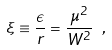Convert formula to latex. <formula><loc_0><loc_0><loc_500><loc_500>\xi \equiv \frac { \epsilon } { r } = \frac { \mu ^ { 2 } } { W ^ { 2 } } \ ,</formula> 